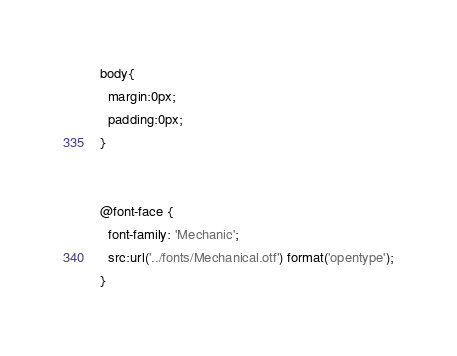<code> <loc_0><loc_0><loc_500><loc_500><_CSS_>body{
  margin:0px;
  padding:0px;
}


@font-face {
  font-family: 'Mechanic';
  src:url('../fonts/Mechanical.otf') format('opentype');
}
</code> 